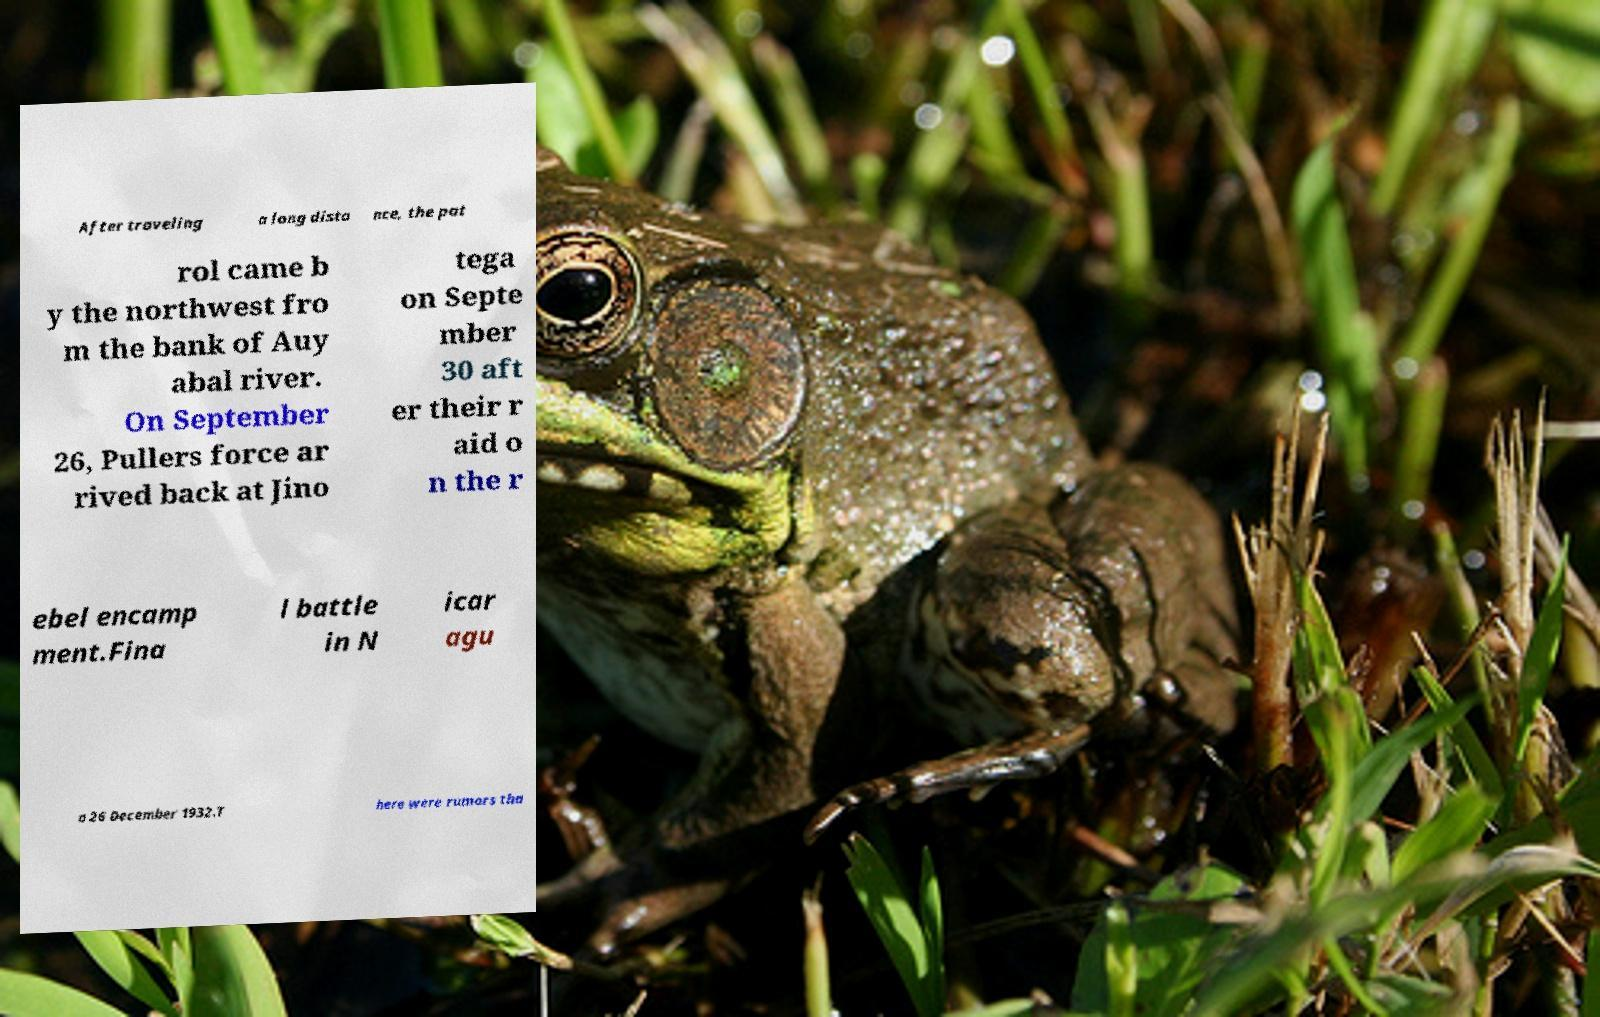Could you assist in decoding the text presented in this image and type it out clearly? After traveling a long dista nce, the pat rol came b y the northwest fro m the bank of Auy abal river. On September 26, Pullers force ar rived back at Jino tega on Septe mber 30 aft er their r aid o n the r ebel encamp ment.Fina l battle in N icar agu a 26 December 1932.T here were rumors tha 